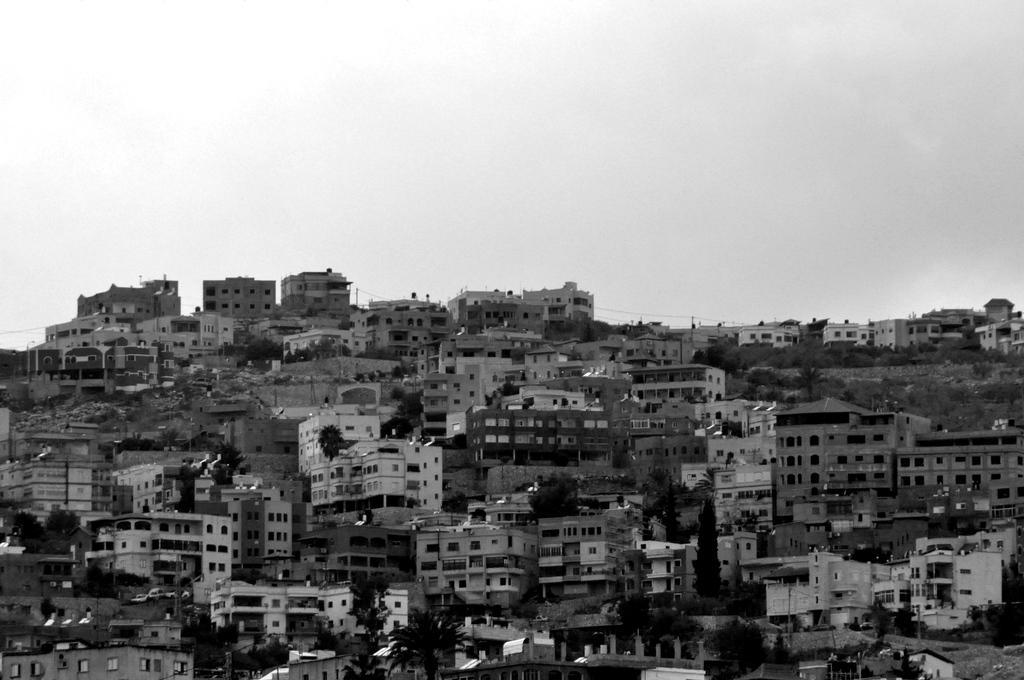Describe this image in one or two sentences. It looks like a black and white picture. We can see there are buildings, trees and the sky. 